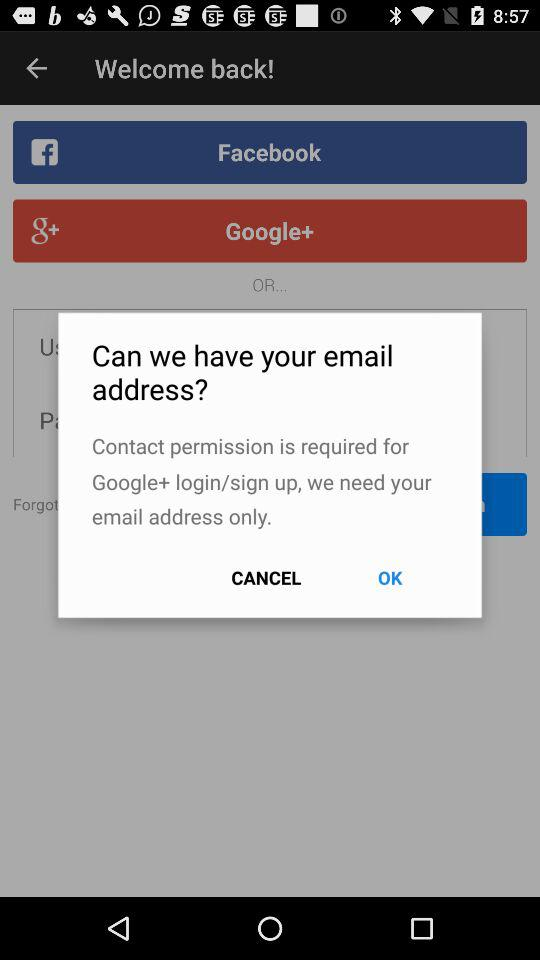Who is logging into their account?
When the provided information is insufficient, respond with <no answer>. <no answer> 